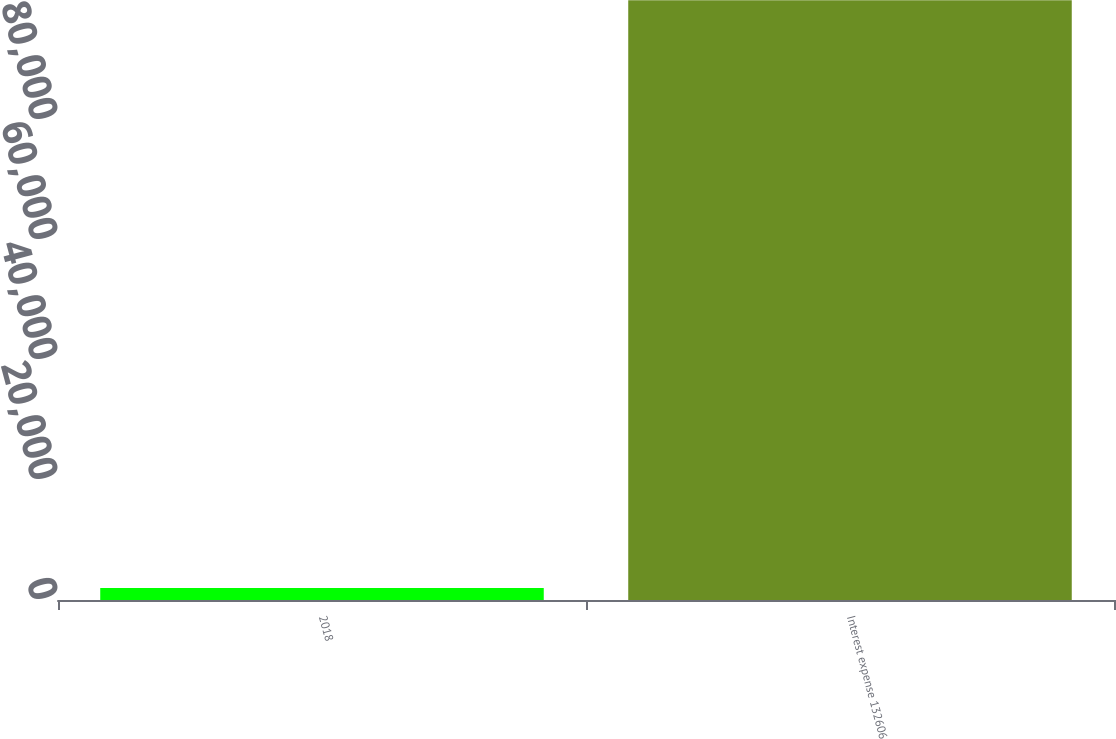Convert chart. <chart><loc_0><loc_0><loc_500><loc_500><bar_chart><fcel>2018<fcel>Interest expense 132606<nl><fcel>2016<fcel>99968<nl></chart> 